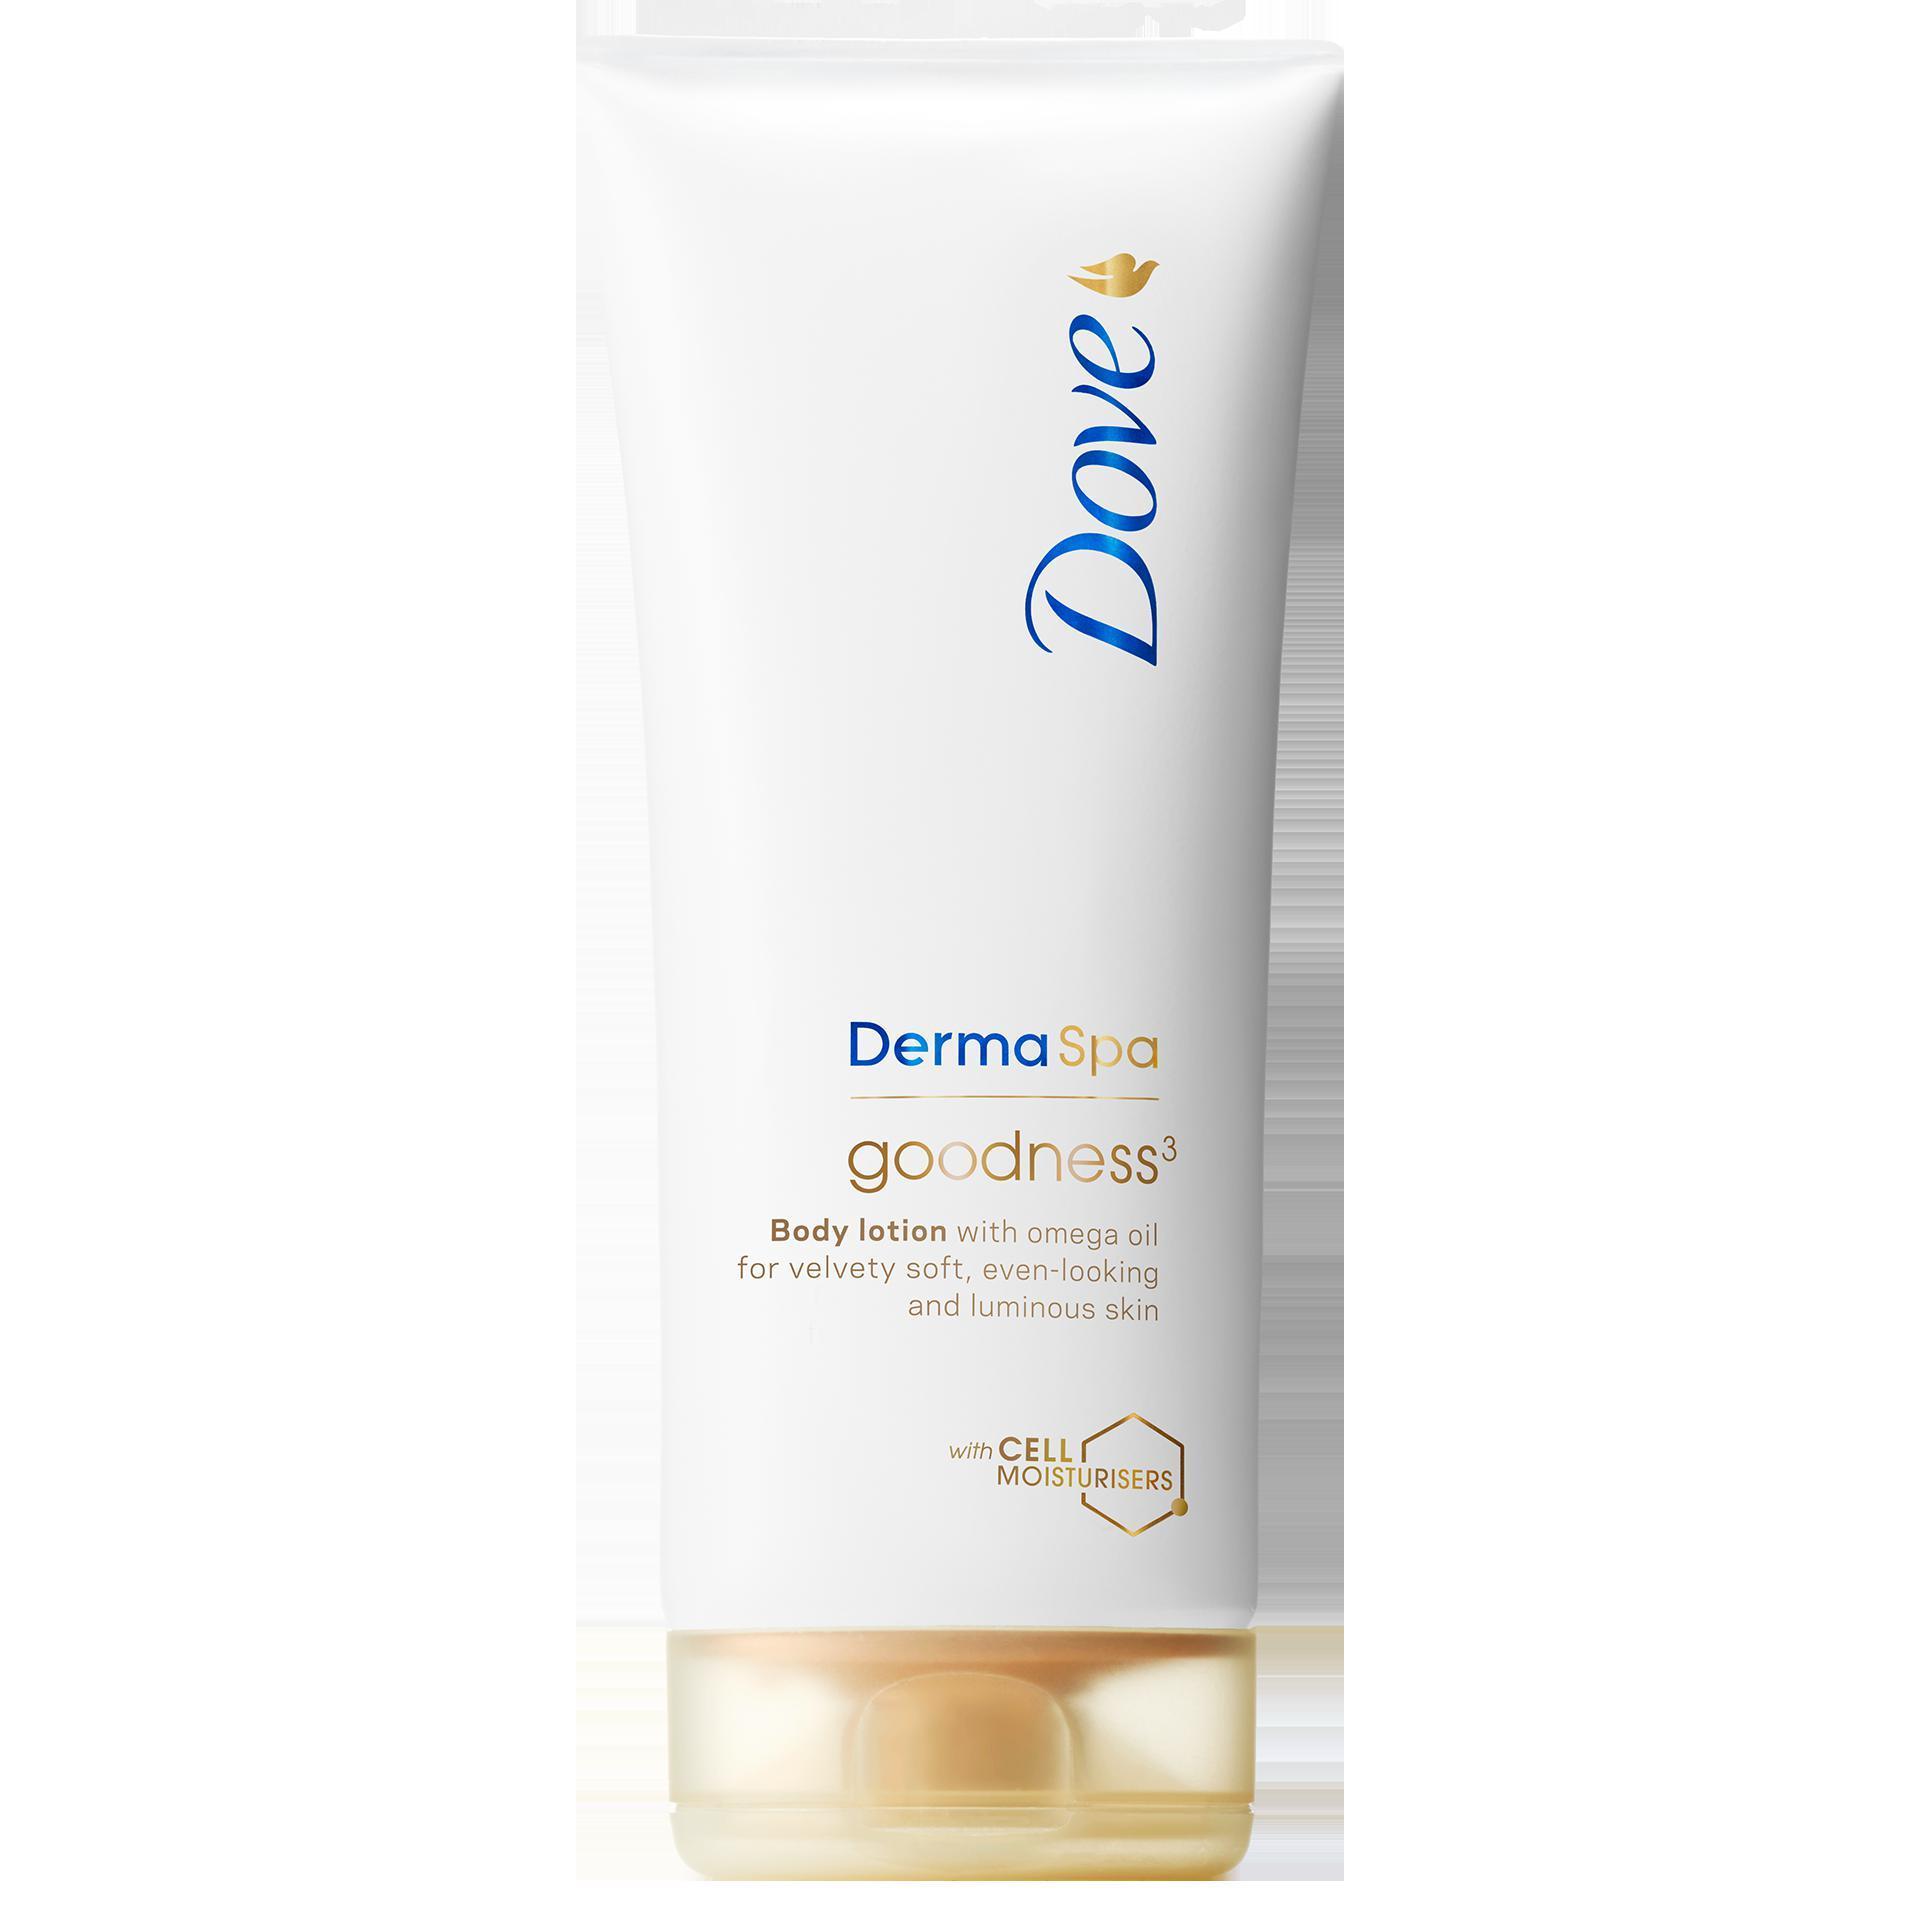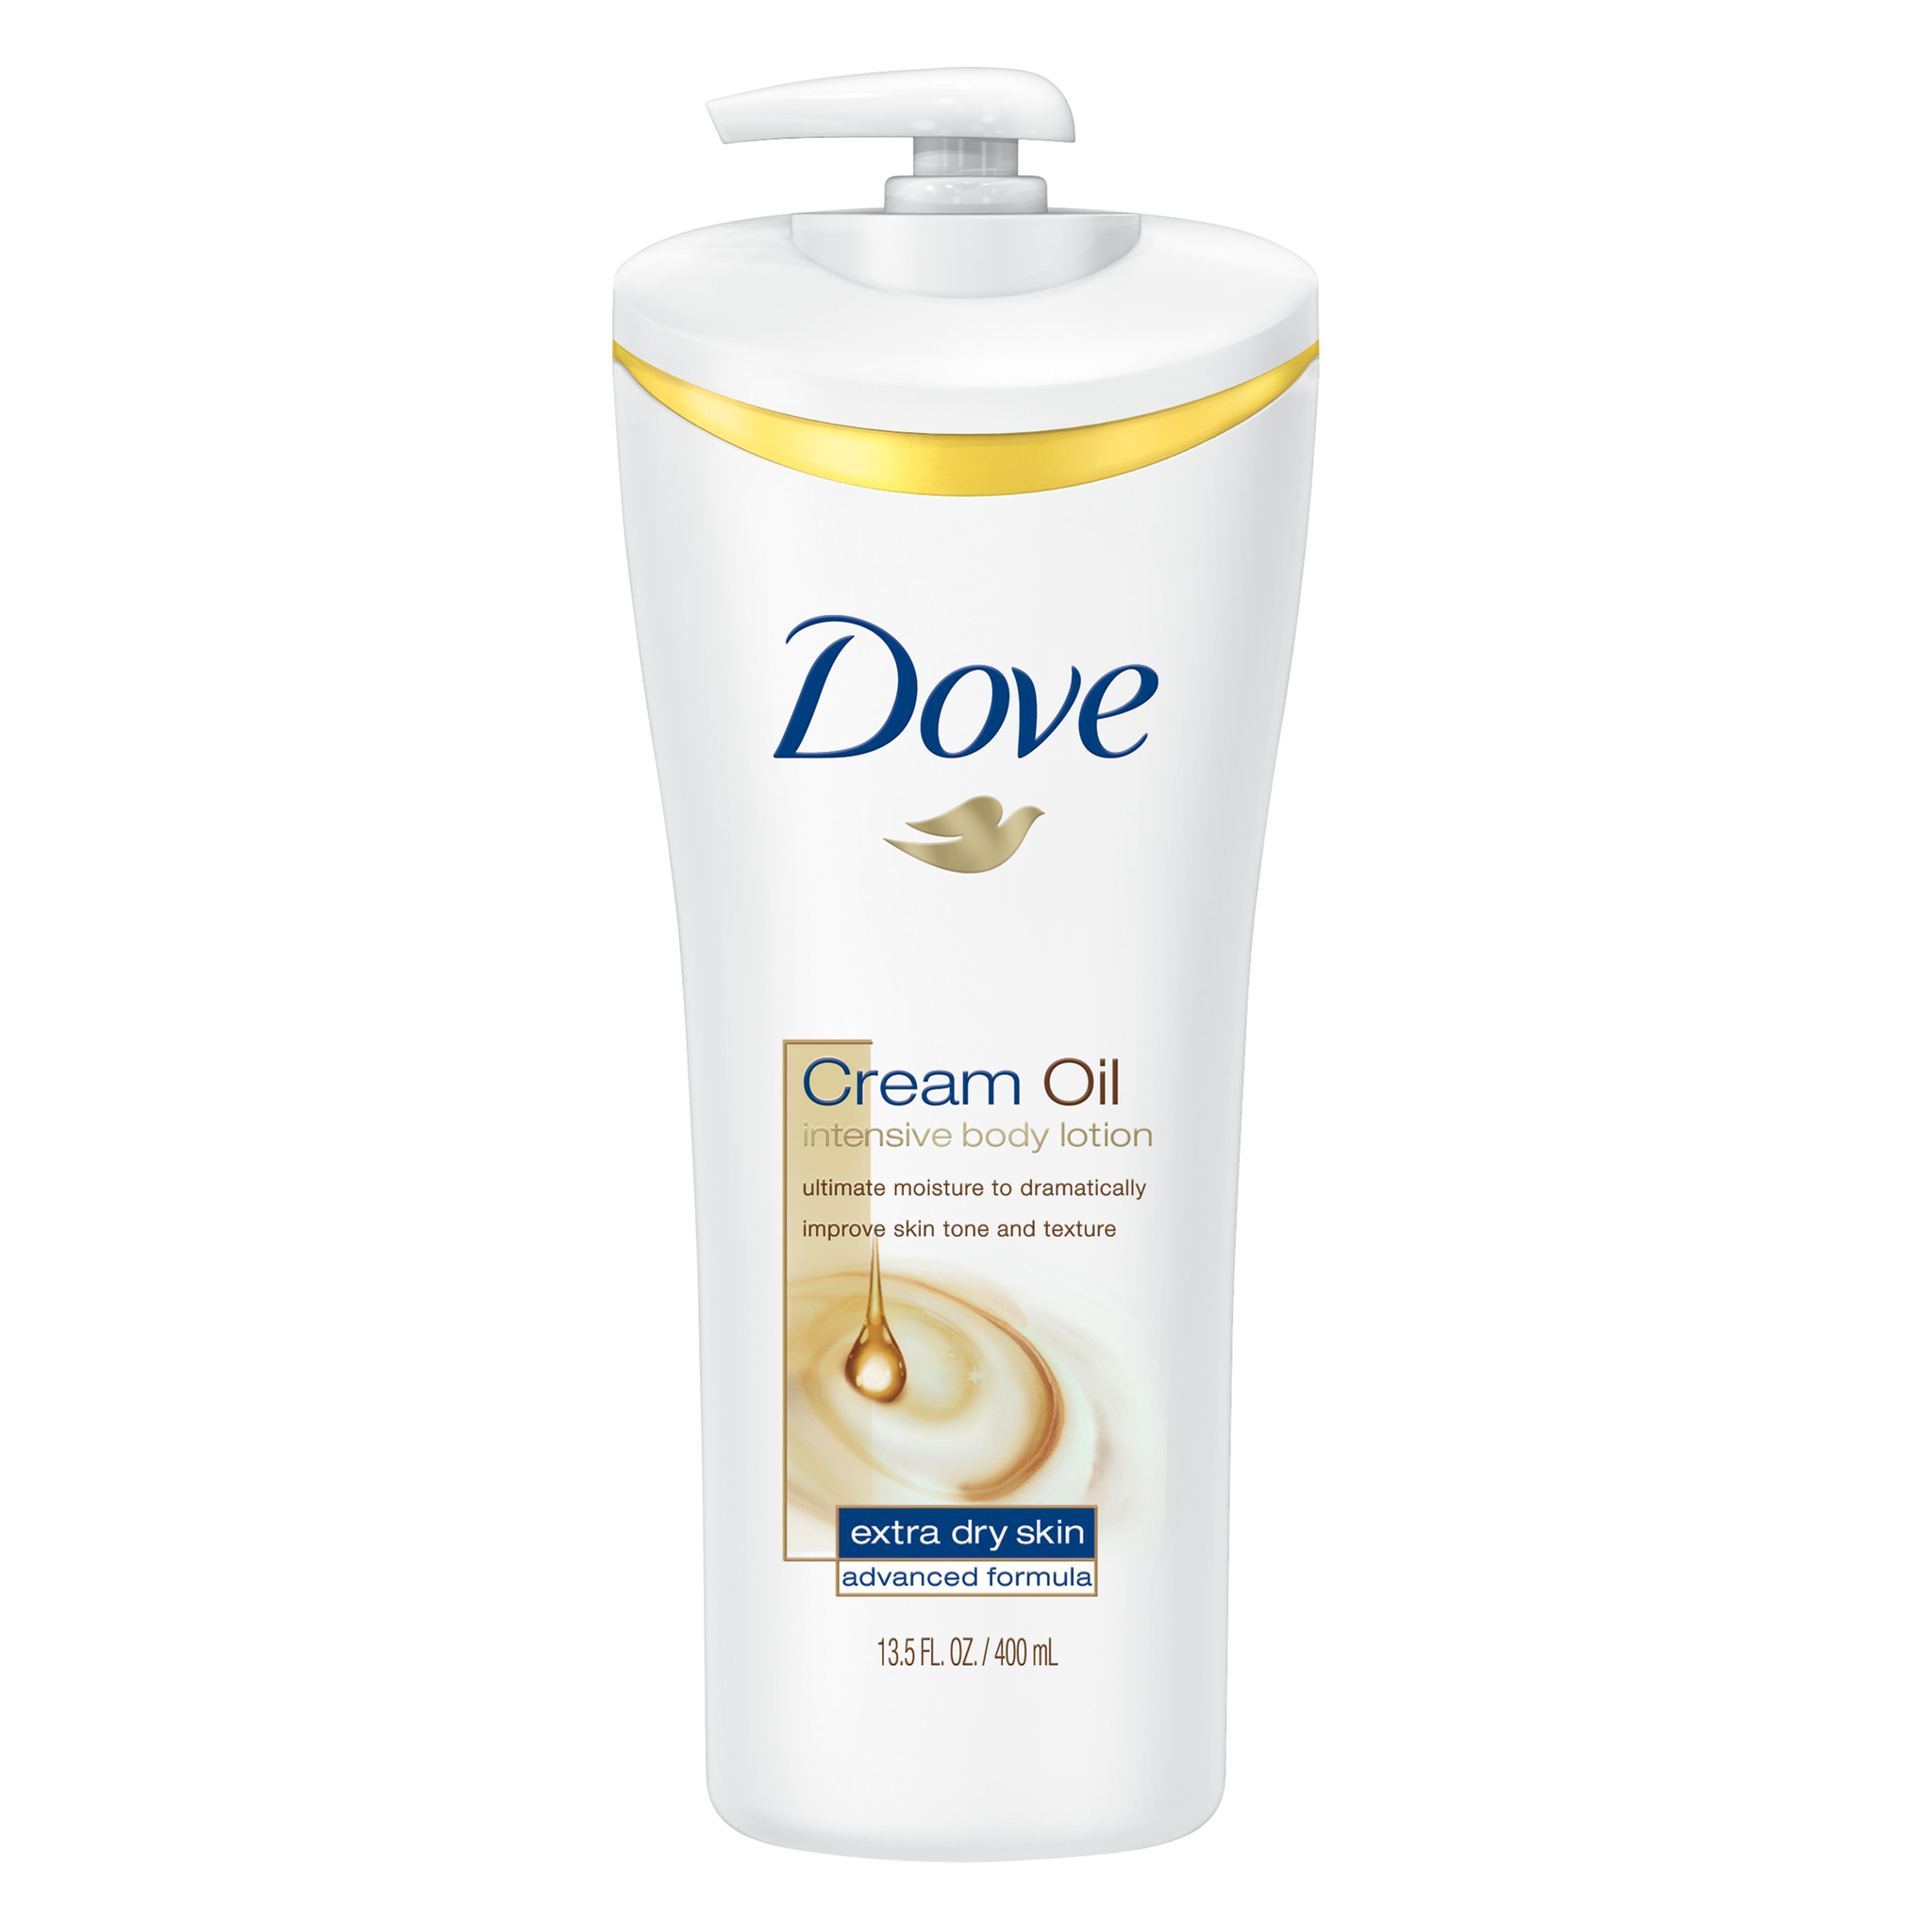The first image is the image on the left, the second image is the image on the right. Evaluate the accuracy of this statement regarding the images: "The right image contains one pump-top product with its nozzle facing left, and the left image contains a product without a pump top.". Is it true? Answer yes or no. Yes. The first image is the image on the left, the second image is the image on the right. Given the left and right images, does the statement "In the image on the right, the bottle of soap has a top pump dispenser." hold true? Answer yes or no. Yes. 